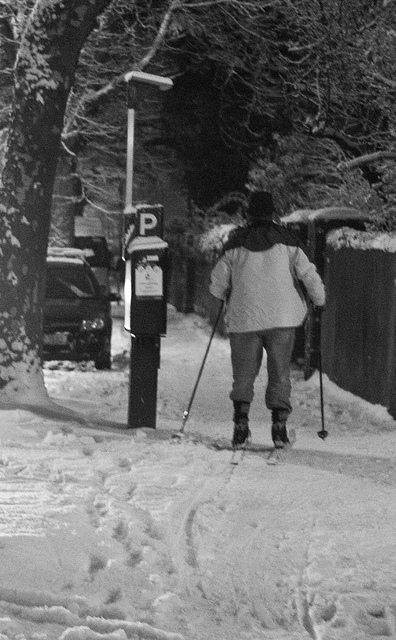Please extract the text content from this image. P 